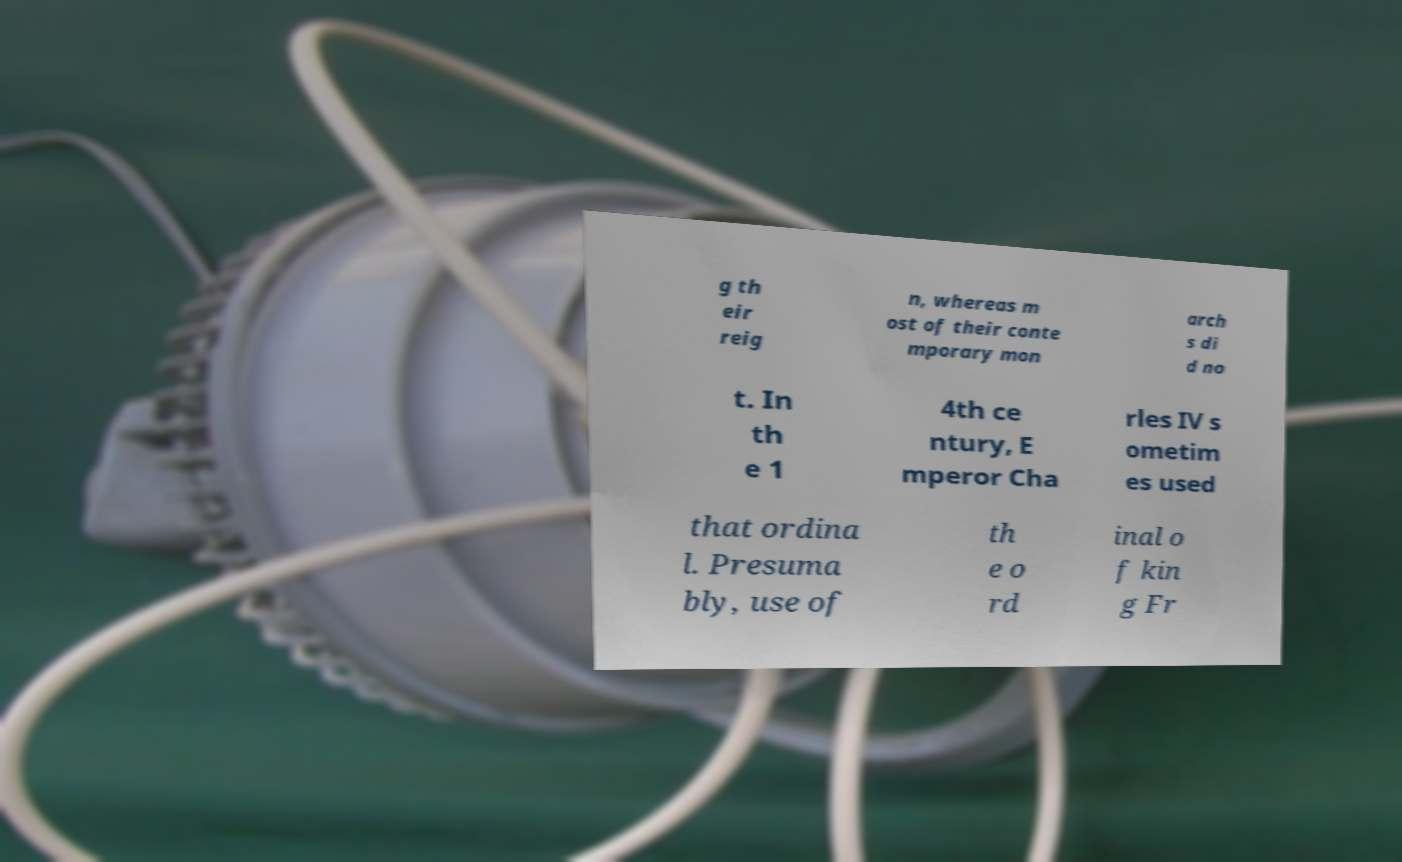For documentation purposes, I need the text within this image transcribed. Could you provide that? g th eir reig n, whereas m ost of their conte mporary mon arch s di d no t. In th e 1 4th ce ntury, E mperor Cha rles IV s ometim es used that ordina l. Presuma bly, use of th e o rd inal o f kin g Fr 